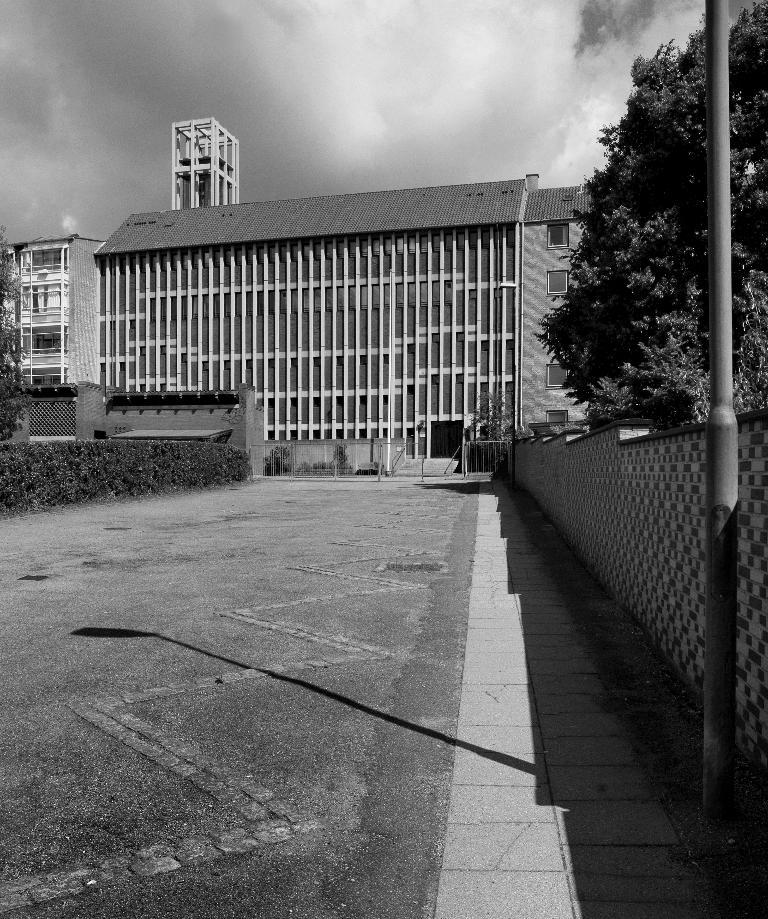What is the main feature of the image? There is a road in the image. What structures or objects are near the road? There is a wall, a pole, and many plants near the road. What can be seen in the background of the image? There are trees, buildings, clouds, and the sky visible in the background of the image. What type of cart is being smashed by the wall in the image? There is no cart present in the image, nor is there any indication of a cart being smashed by the wall. 